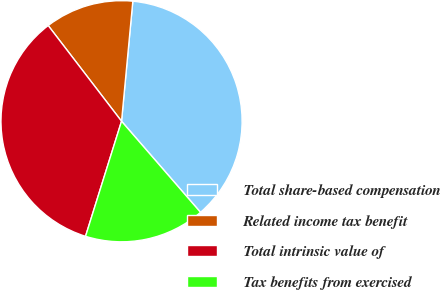Convert chart to OTSL. <chart><loc_0><loc_0><loc_500><loc_500><pie_chart><fcel>Total share-based compensation<fcel>Related income tax benefit<fcel>Total intrinsic value of<fcel>Tax benefits from exercised<nl><fcel>37.14%<fcel>11.9%<fcel>34.76%<fcel>16.19%<nl></chart> 